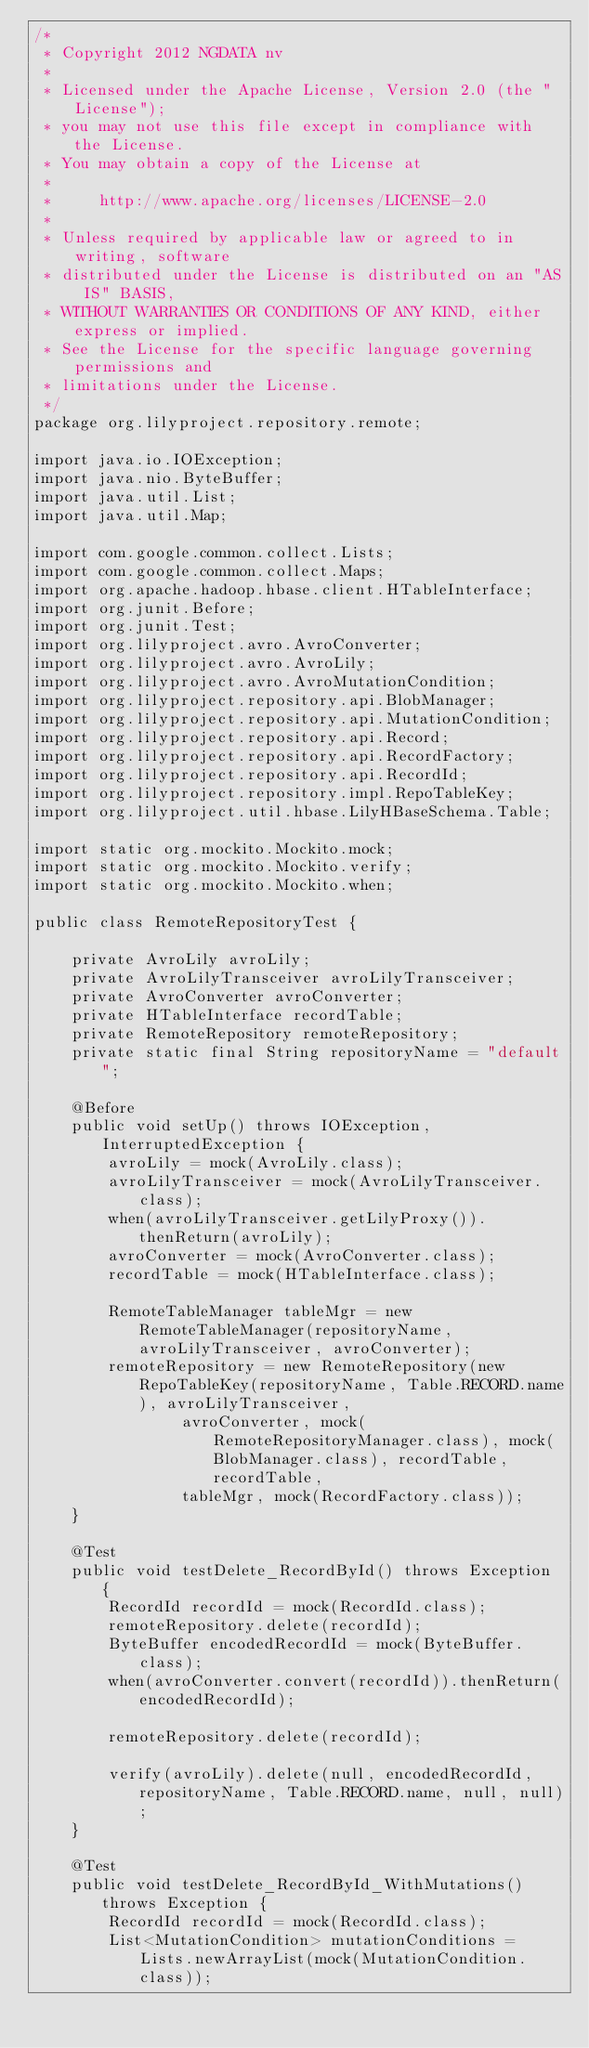Convert code to text. <code><loc_0><loc_0><loc_500><loc_500><_Java_>/*
 * Copyright 2012 NGDATA nv
 *
 * Licensed under the Apache License, Version 2.0 (the "License");
 * you may not use this file except in compliance with the License.
 * You may obtain a copy of the License at
 *
 *     http://www.apache.org/licenses/LICENSE-2.0
 *
 * Unless required by applicable law or agreed to in writing, software
 * distributed under the License is distributed on an "AS IS" BASIS,
 * WITHOUT WARRANTIES OR CONDITIONS OF ANY KIND, either express or implied.
 * See the License for the specific language governing permissions and
 * limitations under the License.
 */
package org.lilyproject.repository.remote;

import java.io.IOException;
import java.nio.ByteBuffer;
import java.util.List;
import java.util.Map;

import com.google.common.collect.Lists;
import com.google.common.collect.Maps;
import org.apache.hadoop.hbase.client.HTableInterface;
import org.junit.Before;
import org.junit.Test;
import org.lilyproject.avro.AvroConverter;
import org.lilyproject.avro.AvroLily;
import org.lilyproject.avro.AvroMutationCondition;
import org.lilyproject.repository.api.BlobManager;
import org.lilyproject.repository.api.MutationCondition;
import org.lilyproject.repository.api.Record;
import org.lilyproject.repository.api.RecordFactory;
import org.lilyproject.repository.api.RecordId;
import org.lilyproject.repository.impl.RepoTableKey;
import org.lilyproject.util.hbase.LilyHBaseSchema.Table;

import static org.mockito.Mockito.mock;
import static org.mockito.Mockito.verify;
import static org.mockito.Mockito.when;

public class RemoteRepositoryTest {

    private AvroLily avroLily;
    private AvroLilyTransceiver avroLilyTransceiver;
    private AvroConverter avroConverter;
    private HTableInterface recordTable;
    private RemoteRepository remoteRepository;
    private static final String repositoryName = "default";

    @Before
    public void setUp() throws IOException, InterruptedException {
        avroLily = mock(AvroLily.class);
        avroLilyTransceiver = mock(AvroLilyTransceiver.class);
        when(avroLilyTransceiver.getLilyProxy()).thenReturn(avroLily);
        avroConverter = mock(AvroConverter.class);
        recordTable = mock(HTableInterface.class);

        RemoteTableManager tableMgr = new RemoteTableManager(repositoryName, avroLilyTransceiver, avroConverter);
        remoteRepository = new RemoteRepository(new RepoTableKey(repositoryName, Table.RECORD.name), avroLilyTransceiver,
                avroConverter, mock(RemoteRepositoryManager.class), mock(BlobManager.class), recordTable, recordTable,
                tableMgr, mock(RecordFactory.class));
    }

    @Test
    public void testDelete_RecordById() throws Exception {
        RecordId recordId = mock(RecordId.class);
        remoteRepository.delete(recordId);
        ByteBuffer encodedRecordId = mock(ByteBuffer.class);
        when(avroConverter.convert(recordId)).thenReturn(encodedRecordId);

        remoteRepository.delete(recordId);

        verify(avroLily).delete(null, encodedRecordId, repositoryName, Table.RECORD.name, null, null);
    }

    @Test
    public void testDelete_RecordById_WithMutations() throws Exception {
        RecordId recordId = mock(RecordId.class);
        List<MutationCondition> mutationConditions = Lists.newArrayList(mock(MutationCondition.class));
</code> 